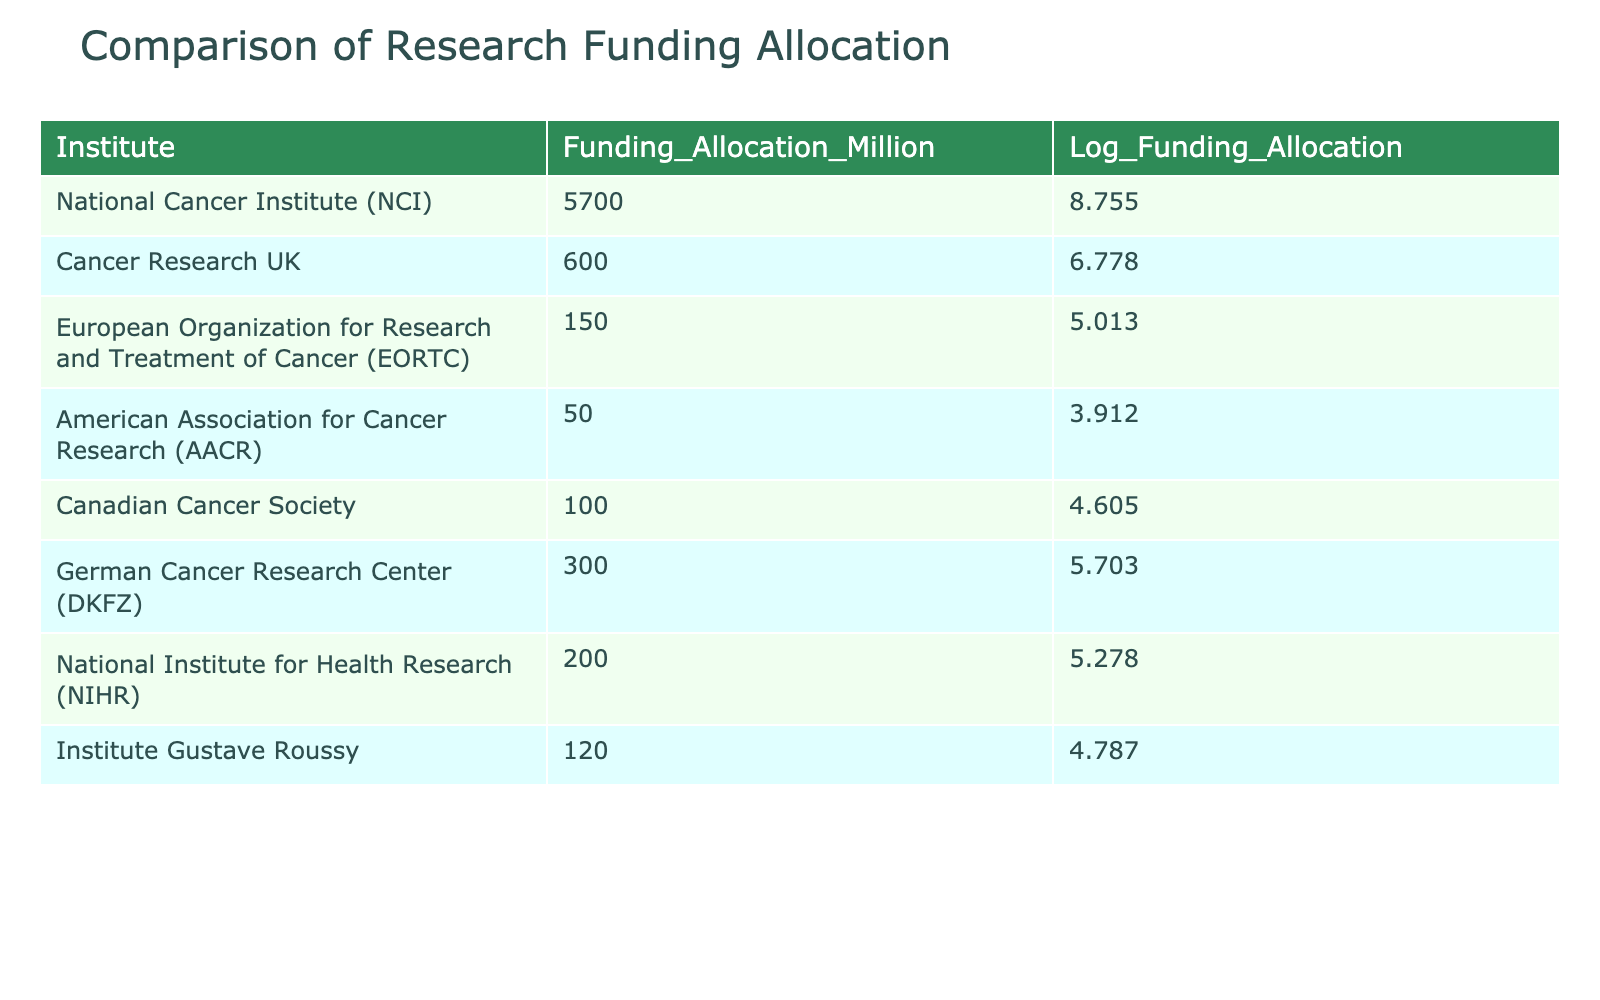What is the funding allocation for the National Cancer Institute? The funding allocation for the National Cancer Institute is provided directly in the table. It shows a value of 5700 million.
Answer: 5700 million Which institute has the highest funding allocation? By examining the "Funding_Allocation_Million" column, it is clear that the National Cancer Institute (NCI) has the highest funding allocation at 5700 million.
Answer: National Cancer Institute (NCI) What is the difference in funding allocation between the Cancer Research UK and the American Association for Cancer Research? The funding allocation for Cancer Research UK is 600 million and for the American Association for Cancer Research is 50 million. The difference is calculated as 600 - 50 = 550 million.
Answer: 550 million Is the funding allocation for the Canadian Cancer Society greater than that for the German Cancer Research Center? The Canadian Cancer Society has a funding allocation of 100 million and the German Cancer Research Center has 300 million. Since 100 is less than 300, the statement is false.
Answer: No What is the total funding allocation for the institutes listed in the table? To find the total funding, we sum all the funding allocations: 5700 + 600 + 150 + 50 + 100 + 300 + 200 + 120 = 6190 million.
Answer: 6190 million What is the average funding allocation across all institutes? First, we sum the funding allocations to get 6190 million and then divide by the number of institutes, which is 8: 6190 / 8 = 773.75 million.
Answer: 773.75 million Is the logarithmic funding allocation for the European Organization for Research and Treatment of Cancer less than 5.5? The logarithmic value for EORTC is 5.013, which is indeed less than 5.5. Therefore, the statement is true.
Answer: Yes What is the logarithmic value for the funding allocation of the Institute Gustave Roussy? The table shows that the logarithmic value for the Institute Gustave Roussy is 4.787.
Answer: 4.787 